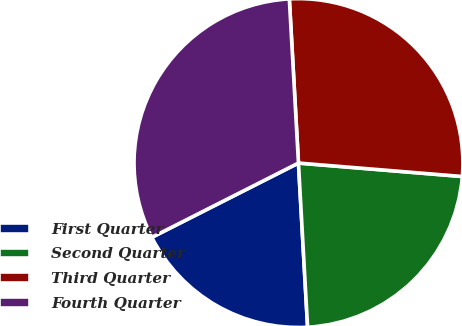Convert chart to OTSL. <chart><loc_0><loc_0><loc_500><loc_500><pie_chart><fcel>First Quarter<fcel>Second Quarter<fcel>Third Quarter<fcel>Fourth Quarter<nl><fcel>18.42%<fcel>22.81%<fcel>27.19%<fcel>31.58%<nl></chart> 